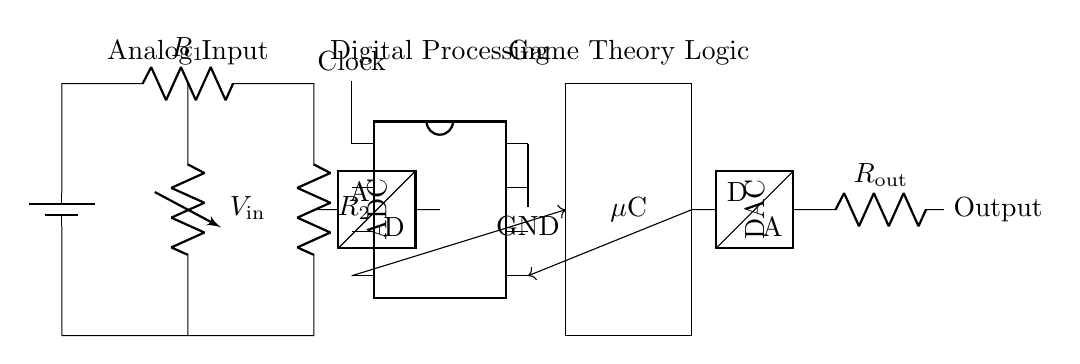What is the function of the battery in this circuit? The battery provides the necessary power supply to drive the circuit's analog components.
Answer: power supply What type of components are R1 and R2? R1 and R2 are resistors, which limit the flow of current in the circuit.
Answer: resistors What is the role of the microcontroller in this circuit? The microcontroller performs digital processing of the input signals and implements game theory logic for the prisoner's dilemma simulation.
Answer: digital processing How many pins does the dip chip have? The dip chip has eight pins as indicated in the circuit diagram.
Answer: eight pins What is connected to pin 1 of the dip chip? Pin 1 of the dip chip is connected to the Clock signal, which is essential for synchronizing operations within the digital section.
Answer: Clock What is the significance of the ADC in this circuit? The ADC (Analog to Digital Converter) converts the analog input voltage into a digital signal for processing by the microcontroller.
Answer: converts analog to digital What type of circuit is this diagram illustrating? This diagram illustrates a hybrid analog-digital circuit combining both analog components and digital processing elements.
Answer: hybrid circuit 